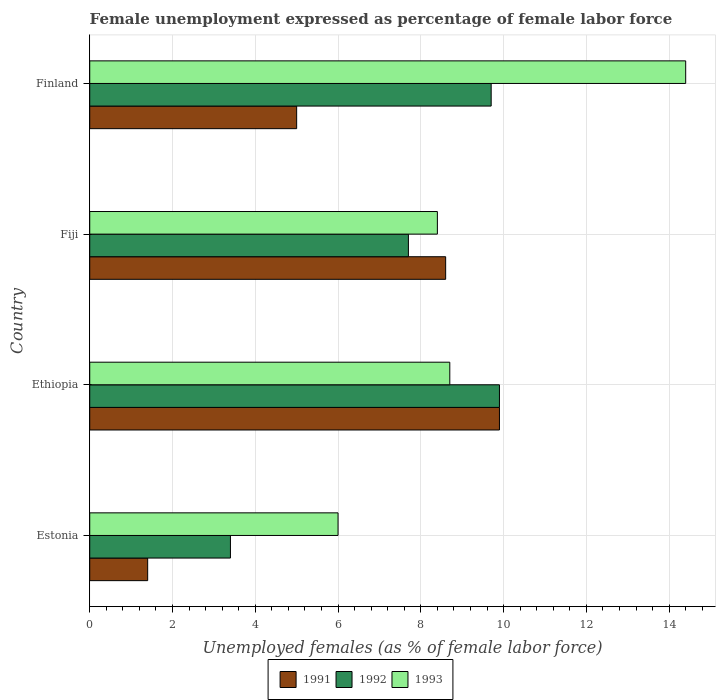What is the label of the 3rd group of bars from the top?
Offer a very short reply. Ethiopia. In how many cases, is the number of bars for a given country not equal to the number of legend labels?
Make the answer very short. 0. What is the unemployment in females in in 1993 in Fiji?
Make the answer very short. 8.4. Across all countries, what is the maximum unemployment in females in in 1991?
Your answer should be compact. 9.9. Across all countries, what is the minimum unemployment in females in in 1991?
Offer a very short reply. 1.4. In which country was the unemployment in females in in 1991 maximum?
Offer a terse response. Ethiopia. In which country was the unemployment in females in in 1991 minimum?
Provide a succinct answer. Estonia. What is the total unemployment in females in in 1992 in the graph?
Ensure brevity in your answer.  30.7. What is the difference between the unemployment in females in in 1991 in Ethiopia and that in Finland?
Your answer should be compact. 4.9. What is the difference between the unemployment in females in in 1992 in Fiji and the unemployment in females in in 1991 in Ethiopia?
Provide a succinct answer. -2.2. What is the average unemployment in females in in 1992 per country?
Your response must be concise. 7.67. What is the difference between the unemployment in females in in 1993 and unemployment in females in in 1992 in Estonia?
Give a very brief answer. 2.6. In how many countries, is the unemployment in females in in 1993 greater than 8 %?
Provide a short and direct response. 3. What is the ratio of the unemployment in females in in 1993 in Estonia to that in Finland?
Provide a short and direct response. 0.42. Is the unemployment in females in in 1991 in Fiji less than that in Finland?
Keep it short and to the point. No. Is the difference between the unemployment in females in in 1993 in Ethiopia and Fiji greater than the difference between the unemployment in females in in 1992 in Ethiopia and Fiji?
Provide a short and direct response. No. What is the difference between the highest and the second highest unemployment in females in in 1992?
Your response must be concise. 0.2. What is the difference between the highest and the lowest unemployment in females in in 1992?
Your response must be concise. 6.5. What does the 2nd bar from the top in Fiji represents?
Keep it short and to the point. 1992. What does the 1st bar from the bottom in Ethiopia represents?
Your answer should be very brief. 1991. How many bars are there?
Ensure brevity in your answer.  12. Does the graph contain grids?
Keep it short and to the point. Yes. Where does the legend appear in the graph?
Ensure brevity in your answer.  Bottom center. What is the title of the graph?
Your response must be concise. Female unemployment expressed as percentage of female labor force. What is the label or title of the X-axis?
Make the answer very short. Unemployed females (as % of female labor force). What is the label or title of the Y-axis?
Offer a very short reply. Country. What is the Unemployed females (as % of female labor force) in 1991 in Estonia?
Provide a succinct answer. 1.4. What is the Unemployed females (as % of female labor force) in 1992 in Estonia?
Provide a succinct answer. 3.4. What is the Unemployed females (as % of female labor force) of 1993 in Estonia?
Make the answer very short. 6. What is the Unemployed females (as % of female labor force) in 1991 in Ethiopia?
Provide a succinct answer. 9.9. What is the Unemployed females (as % of female labor force) in 1992 in Ethiopia?
Your answer should be very brief. 9.9. What is the Unemployed females (as % of female labor force) of 1993 in Ethiopia?
Your response must be concise. 8.7. What is the Unemployed females (as % of female labor force) in 1991 in Fiji?
Make the answer very short. 8.6. What is the Unemployed females (as % of female labor force) of 1992 in Fiji?
Your answer should be compact. 7.7. What is the Unemployed females (as % of female labor force) of 1993 in Fiji?
Keep it short and to the point. 8.4. What is the Unemployed females (as % of female labor force) of 1992 in Finland?
Give a very brief answer. 9.7. What is the Unemployed females (as % of female labor force) in 1993 in Finland?
Provide a short and direct response. 14.4. Across all countries, what is the maximum Unemployed females (as % of female labor force) of 1991?
Offer a terse response. 9.9. Across all countries, what is the maximum Unemployed females (as % of female labor force) of 1992?
Offer a very short reply. 9.9. Across all countries, what is the maximum Unemployed females (as % of female labor force) of 1993?
Keep it short and to the point. 14.4. Across all countries, what is the minimum Unemployed females (as % of female labor force) of 1991?
Offer a very short reply. 1.4. Across all countries, what is the minimum Unemployed females (as % of female labor force) in 1992?
Provide a short and direct response. 3.4. What is the total Unemployed females (as % of female labor force) in 1991 in the graph?
Offer a very short reply. 24.9. What is the total Unemployed females (as % of female labor force) of 1992 in the graph?
Give a very brief answer. 30.7. What is the total Unemployed females (as % of female labor force) in 1993 in the graph?
Your answer should be very brief. 37.5. What is the difference between the Unemployed females (as % of female labor force) in 1993 in Estonia and that in Ethiopia?
Offer a terse response. -2.7. What is the difference between the Unemployed females (as % of female labor force) in 1993 in Estonia and that in Fiji?
Offer a very short reply. -2.4. What is the difference between the Unemployed females (as % of female labor force) of 1992 in Estonia and that in Finland?
Provide a succinct answer. -6.3. What is the difference between the Unemployed females (as % of female labor force) in 1993 in Estonia and that in Finland?
Your answer should be compact. -8.4. What is the difference between the Unemployed females (as % of female labor force) of 1991 in Ethiopia and that in Fiji?
Ensure brevity in your answer.  1.3. What is the difference between the Unemployed females (as % of female labor force) in 1991 in Ethiopia and that in Finland?
Your answer should be compact. 4.9. What is the difference between the Unemployed females (as % of female labor force) in 1992 in Ethiopia and that in Finland?
Your answer should be compact. 0.2. What is the difference between the Unemployed females (as % of female labor force) in 1992 in Fiji and that in Finland?
Keep it short and to the point. -2. What is the difference between the Unemployed females (as % of female labor force) of 1993 in Fiji and that in Finland?
Your response must be concise. -6. What is the difference between the Unemployed females (as % of female labor force) in 1991 in Estonia and the Unemployed females (as % of female labor force) in 1992 in Ethiopia?
Offer a terse response. -8.5. What is the difference between the Unemployed females (as % of female labor force) in 1991 in Estonia and the Unemployed females (as % of female labor force) in 1993 in Ethiopia?
Your answer should be very brief. -7.3. What is the difference between the Unemployed females (as % of female labor force) in 1991 in Estonia and the Unemployed females (as % of female labor force) in 1993 in Fiji?
Your response must be concise. -7. What is the difference between the Unemployed females (as % of female labor force) of 1992 in Estonia and the Unemployed females (as % of female labor force) of 1993 in Fiji?
Offer a terse response. -5. What is the difference between the Unemployed females (as % of female labor force) in 1992 in Ethiopia and the Unemployed females (as % of female labor force) in 1993 in Fiji?
Give a very brief answer. 1.5. What is the difference between the Unemployed females (as % of female labor force) in 1991 in Ethiopia and the Unemployed females (as % of female labor force) in 1992 in Finland?
Give a very brief answer. 0.2. What is the difference between the Unemployed females (as % of female labor force) in 1991 in Fiji and the Unemployed females (as % of female labor force) in 1992 in Finland?
Provide a short and direct response. -1.1. What is the difference between the Unemployed females (as % of female labor force) of 1991 in Fiji and the Unemployed females (as % of female labor force) of 1993 in Finland?
Offer a terse response. -5.8. What is the difference between the Unemployed females (as % of female labor force) of 1992 in Fiji and the Unemployed females (as % of female labor force) of 1993 in Finland?
Give a very brief answer. -6.7. What is the average Unemployed females (as % of female labor force) of 1991 per country?
Give a very brief answer. 6.22. What is the average Unemployed females (as % of female labor force) of 1992 per country?
Provide a succinct answer. 7.67. What is the average Unemployed females (as % of female labor force) in 1993 per country?
Make the answer very short. 9.38. What is the difference between the Unemployed females (as % of female labor force) in 1991 and Unemployed females (as % of female labor force) in 1992 in Estonia?
Offer a very short reply. -2. What is the difference between the Unemployed females (as % of female labor force) of 1992 and Unemployed females (as % of female labor force) of 1993 in Estonia?
Make the answer very short. -2.6. What is the difference between the Unemployed females (as % of female labor force) in 1991 and Unemployed females (as % of female labor force) in 1992 in Ethiopia?
Offer a very short reply. 0. What is the difference between the Unemployed females (as % of female labor force) of 1992 and Unemployed females (as % of female labor force) of 1993 in Ethiopia?
Offer a very short reply. 1.2. What is the difference between the Unemployed females (as % of female labor force) of 1991 and Unemployed females (as % of female labor force) of 1992 in Fiji?
Make the answer very short. 0.9. What is the difference between the Unemployed females (as % of female labor force) in 1992 and Unemployed females (as % of female labor force) in 1993 in Fiji?
Offer a terse response. -0.7. What is the difference between the Unemployed females (as % of female labor force) in 1992 and Unemployed females (as % of female labor force) in 1993 in Finland?
Provide a short and direct response. -4.7. What is the ratio of the Unemployed females (as % of female labor force) in 1991 in Estonia to that in Ethiopia?
Keep it short and to the point. 0.14. What is the ratio of the Unemployed females (as % of female labor force) of 1992 in Estonia to that in Ethiopia?
Provide a succinct answer. 0.34. What is the ratio of the Unemployed females (as % of female labor force) in 1993 in Estonia to that in Ethiopia?
Keep it short and to the point. 0.69. What is the ratio of the Unemployed females (as % of female labor force) of 1991 in Estonia to that in Fiji?
Ensure brevity in your answer.  0.16. What is the ratio of the Unemployed females (as % of female labor force) of 1992 in Estonia to that in Fiji?
Make the answer very short. 0.44. What is the ratio of the Unemployed females (as % of female labor force) in 1993 in Estonia to that in Fiji?
Provide a short and direct response. 0.71. What is the ratio of the Unemployed females (as % of female labor force) of 1991 in Estonia to that in Finland?
Offer a very short reply. 0.28. What is the ratio of the Unemployed females (as % of female labor force) of 1992 in Estonia to that in Finland?
Your response must be concise. 0.35. What is the ratio of the Unemployed females (as % of female labor force) in 1993 in Estonia to that in Finland?
Give a very brief answer. 0.42. What is the ratio of the Unemployed females (as % of female labor force) in 1991 in Ethiopia to that in Fiji?
Make the answer very short. 1.15. What is the ratio of the Unemployed females (as % of female labor force) in 1993 in Ethiopia to that in Fiji?
Provide a short and direct response. 1.04. What is the ratio of the Unemployed females (as % of female labor force) of 1991 in Ethiopia to that in Finland?
Offer a very short reply. 1.98. What is the ratio of the Unemployed females (as % of female labor force) of 1992 in Ethiopia to that in Finland?
Offer a very short reply. 1.02. What is the ratio of the Unemployed females (as % of female labor force) in 1993 in Ethiopia to that in Finland?
Give a very brief answer. 0.6. What is the ratio of the Unemployed females (as % of female labor force) in 1991 in Fiji to that in Finland?
Give a very brief answer. 1.72. What is the ratio of the Unemployed females (as % of female labor force) in 1992 in Fiji to that in Finland?
Your answer should be compact. 0.79. What is the ratio of the Unemployed females (as % of female labor force) of 1993 in Fiji to that in Finland?
Make the answer very short. 0.58. What is the difference between the highest and the second highest Unemployed females (as % of female labor force) in 1991?
Your response must be concise. 1.3. What is the difference between the highest and the second highest Unemployed females (as % of female labor force) in 1992?
Your answer should be very brief. 0.2. 